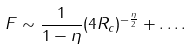Convert formula to latex. <formula><loc_0><loc_0><loc_500><loc_500>F \sim \frac { 1 } { 1 - \eta } ( 4 R _ { c } ) ^ { - \frac { \eta } { 2 } } + \dots .</formula> 